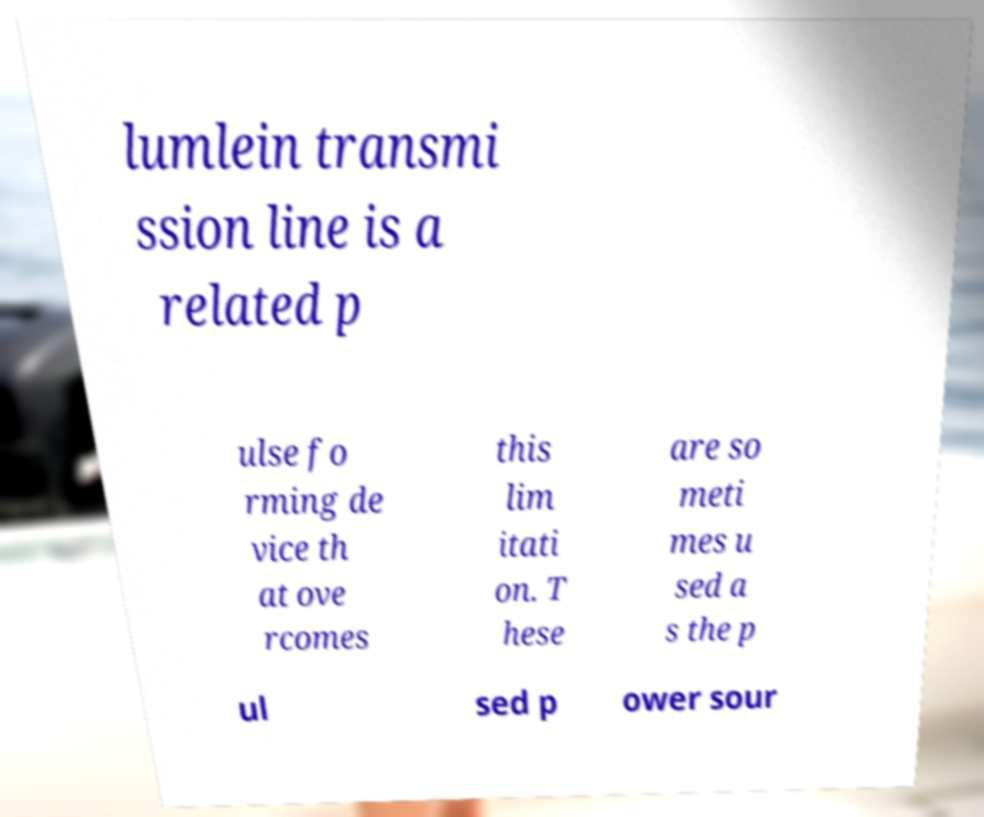Can you read and provide the text displayed in the image?This photo seems to have some interesting text. Can you extract and type it out for me? lumlein transmi ssion line is a related p ulse fo rming de vice th at ove rcomes this lim itati on. T hese are so meti mes u sed a s the p ul sed p ower sour 